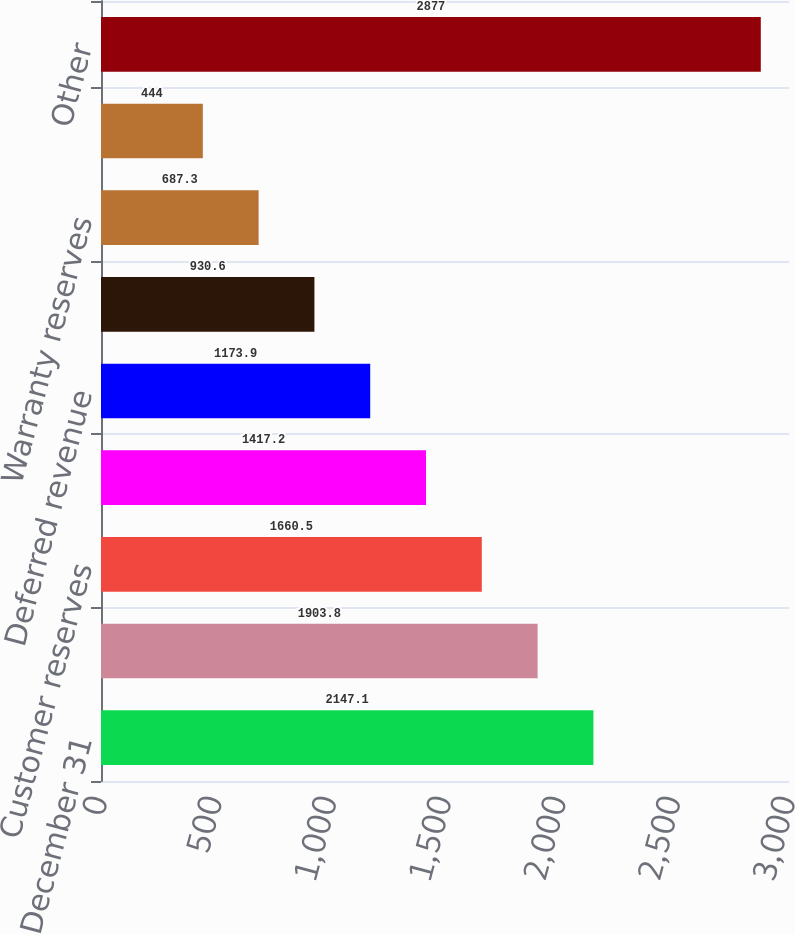Convert chart to OTSL. <chart><loc_0><loc_0><loc_500><loc_500><bar_chart><fcel>December 31<fcel>Contractor payables<fcel>Customer reserves<fcel>Compensation<fcel>Deferred revenue<fcel>Customer downpayments<fcel>Warranty reserves<fcel>Tax liabilities<fcel>Other<nl><fcel>2147.1<fcel>1903.8<fcel>1660.5<fcel>1417.2<fcel>1173.9<fcel>930.6<fcel>687.3<fcel>444<fcel>2877<nl></chart> 